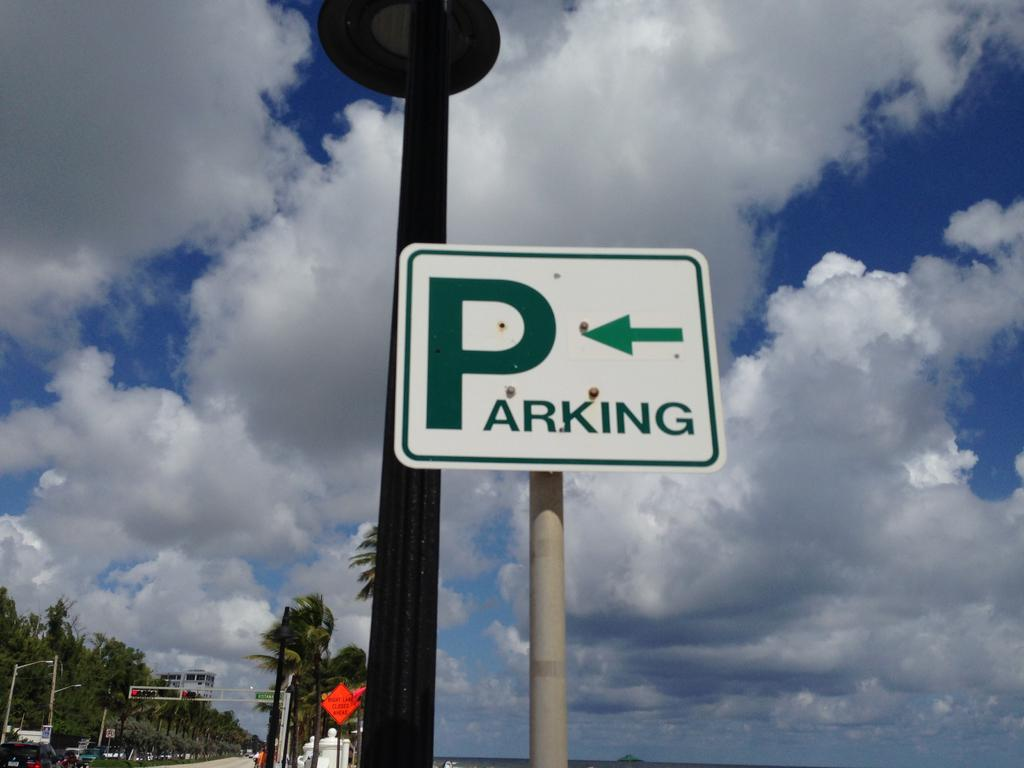What is the main object in the image? There is a sign board in the image. What can be seen in the background of the image? There are trees and the sky visible in the background of the image. What is the name of the person holding the dolls in the image? There are no people or dolls present in the image, so there is no name to provide. 